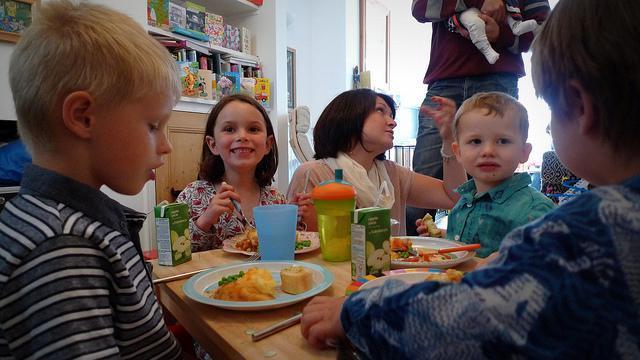How many children are there?
Give a very brief answer. 4. How many of the children are boys?
Give a very brief answer. 3. How many people are at the table?
Give a very brief answer. 5. How many children are in the image?
Give a very brief answer. 4. How many girls are in the picture?
Give a very brief answer. 2. How many cups can be seen?
Give a very brief answer. 2. How many people are in the picture?
Give a very brief answer. 6. How many yellow bikes are there?
Give a very brief answer. 0. 